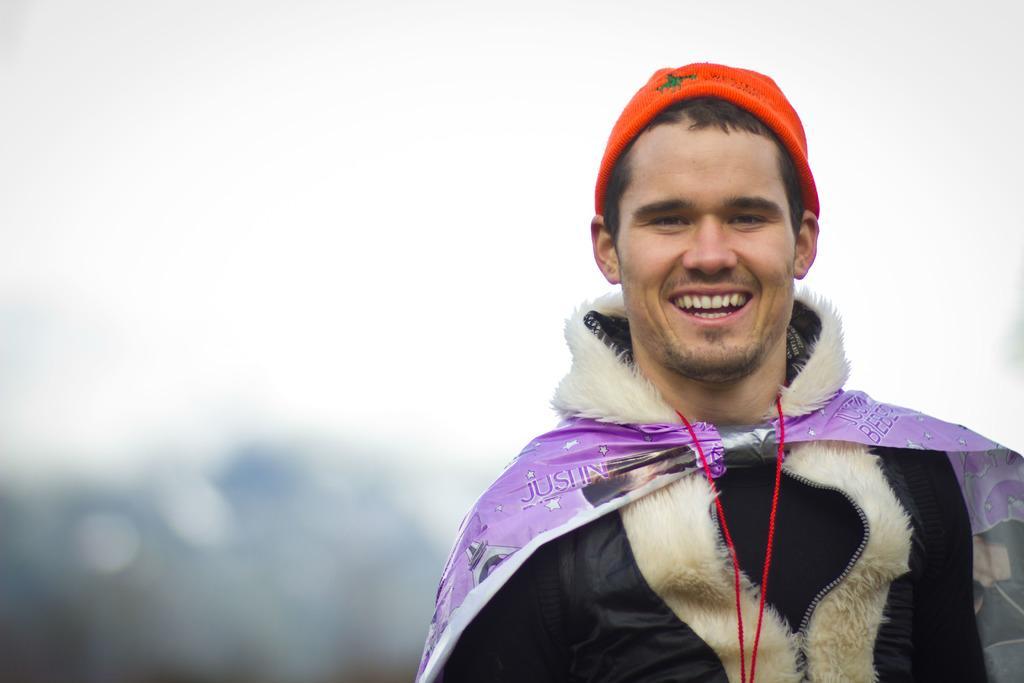Can you describe this image briefly? In this image we can see persons standing and wearing a cap. In the background there is sky. 